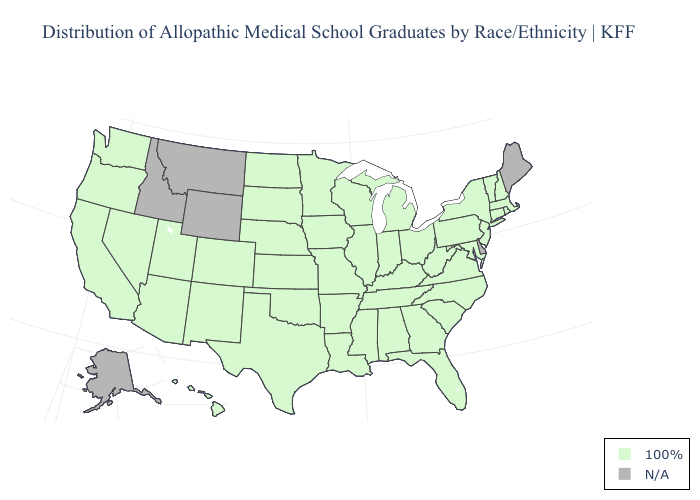Name the states that have a value in the range 100%?
Keep it brief. Alabama, Arizona, Arkansas, California, Colorado, Connecticut, Florida, Georgia, Hawaii, Illinois, Indiana, Iowa, Kansas, Kentucky, Louisiana, Maryland, Massachusetts, Michigan, Minnesota, Mississippi, Missouri, Nebraska, Nevada, New Hampshire, New Jersey, New Mexico, New York, North Carolina, North Dakota, Ohio, Oklahoma, Oregon, Pennsylvania, Rhode Island, South Carolina, South Dakota, Tennessee, Texas, Utah, Vermont, Virginia, Washington, West Virginia, Wisconsin. Does the first symbol in the legend represent the smallest category?
Write a very short answer. Yes. What is the lowest value in states that border Georgia?
Keep it brief. 100%. What is the highest value in the Northeast ?
Write a very short answer. 100%. Does the first symbol in the legend represent the smallest category?
Short answer required. Yes. Name the states that have a value in the range N/A?
Quick response, please. Alaska, Delaware, Idaho, Maine, Montana, Wyoming. Which states have the highest value in the USA?
Answer briefly. Alabama, Arizona, Arkansas, California, Colorado, Connecticut, Florida, Georgia, Hawaii, Illinois, Indiana, Iowa, Kansas, Kentucky, Louisiana, Maryland, Massachusetts, Michigan, Minnesota, Mississippi, Missouri, Nebraska, Nevada, New Hampshire, New Jersey, New Mexico, New York, North Carolina, North Dakota, Ohio, Oklahoma, Oregon, Pennsylvania, Rhode Island, South Carolina, South Dakota, Tennessee, Texas, Utah, Vermont, Virginia, Washington, West Virginia, Wisconsin. Name the states that have a value in the range N/A?
Concise answer only. Alaska, Delaware, Idaho, Maine, Montana, Wyoming. Name the states that have a value in the range N/A?
Answer briefly. Alaska, Delaware, Idaho, Maine, Montana, Wyoming. What is the lowest value in the USA?
Be succinct. 100%. Is the legend a continuous bar?
Keep it brief. No. What is the value of Oregon?
Short answer required. 100%. Name the states that have a value in the range N/A?
Quick response, please. Alaska, Delaware, Idaho, Maine, Montana, Wyoming. 